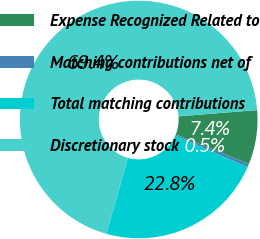Convert chart. <chart><loc_0><loc_0><loc_500><loc_500><pie_chart><fcel>Expense Recognized Related to<fcel>Matching contributions net of<fcel>Total matching contributions<fcel>Discretionary stock<nl><fcel>7.36%<fcel>0.47%<fcel>22.82%<fcel>69.36%<nl></chart> 